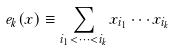Convert formula to latex. <formula><loc_0><loc_0><loc_500><loc_500>e _ { k } ( x ) \equiv \sum _ { i _ { 1 } < \cdots < i _ { k } } x _ { i _ { 1 } } \cdots x _ { i _ { k } }</formula> 